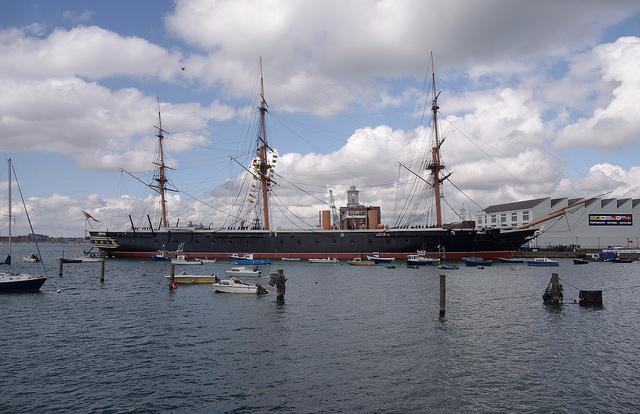What mode of transport is in the above picture? ship 